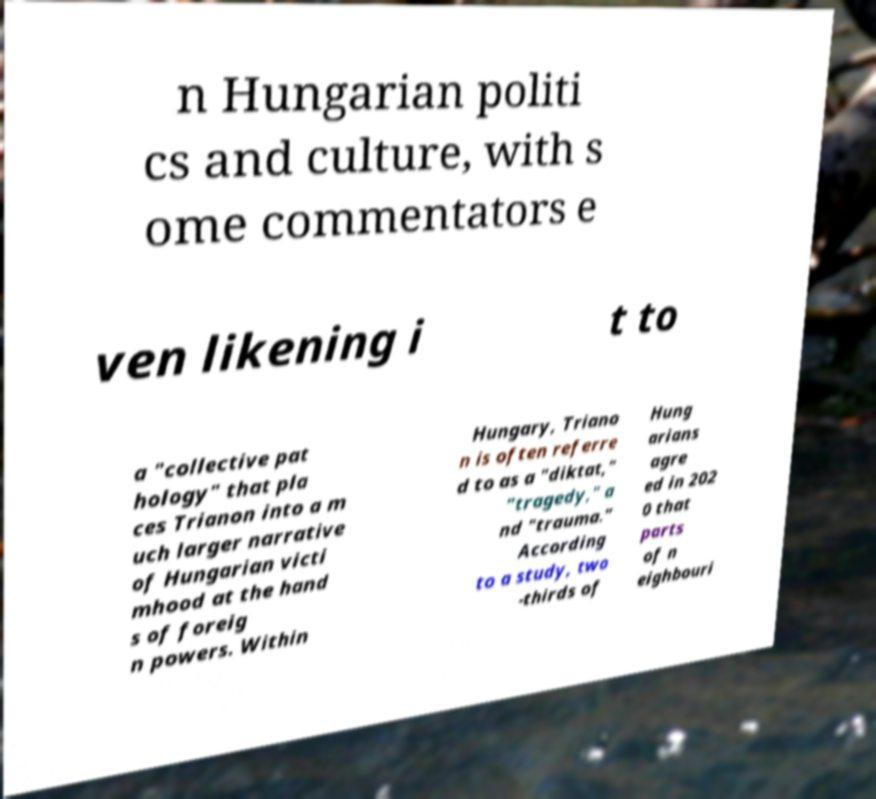For documentation purposes, I need the text within this image transcribed. Could you provide that? n Hungarian politi cs and culture, with s ome commentators e ven likening i t to a "collective pat hology" that pla ces Trianon into a m uch larger narrative of Hungarian victi mhood at the hand s of foreig n powers. Within Hungary, Triano n is often referre d to as a "diktat," "tragedy," a nd "trauma." According to a study, two -thirds of Hung arians agre ed in 202 0 that parts of n eighbouri 